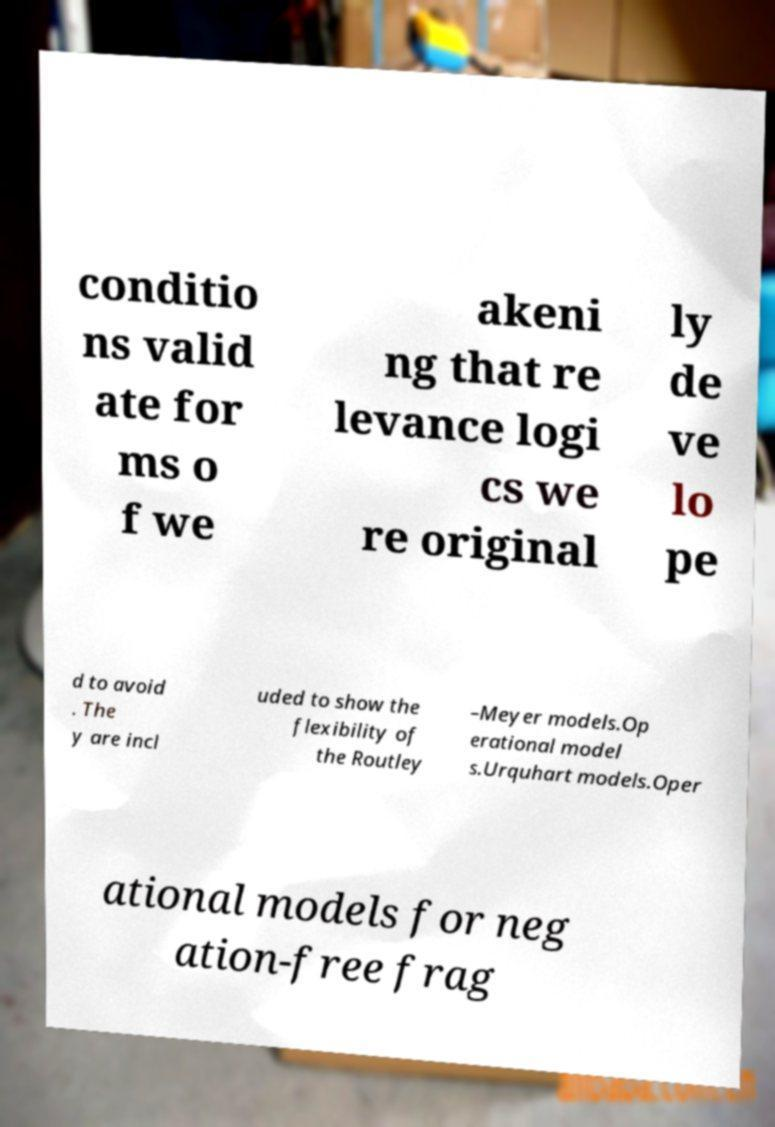What messages or text are displayed in this image? I need them in a readable, typed format. conditio ns valid ate for ms o f we akeni ng that re levance logi cs we re original ly de ve lo pe d to avoid . The y are incl uded to show the flexibility of the Routley –Meyer models.Op erational model s.Urquhart models.Oper ational models for neg ation-free frag 